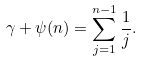<formula> <loc_0><loc_0><loc_500><loc_500>\gamma + \psi ( n ) = \sum _ { j = 1 } ^ { n - 1 } \frac { 1 } { j } .</formula> 